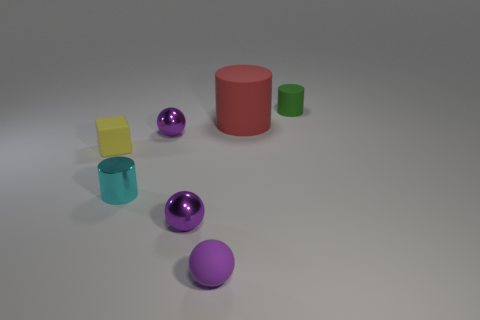Subtract all rubber cylinders. How many cylinders are left? 1 Add 2 purple rubber things. How many objects exist? 9 Subtract all green cylinders. How many cylinders are left? 2 Subtract 1 cylinders. How many cylinders are left? 2 Subtract all blocks. How many objects are left? 6 Add 6 green rubber things. How many green rubber things are left? 7 Add 2 green cylinders. How many green cylinders exist? 3 Subtract 1 cyan cylinders. How many objects are left? 6 Subtract all yellow cylinders. Subtract all blue balls. How many cylinders are left? 3 Subtract all large red shiny cylinders. Subtract all tiny purple rubber objects. How many objects are left? 6 